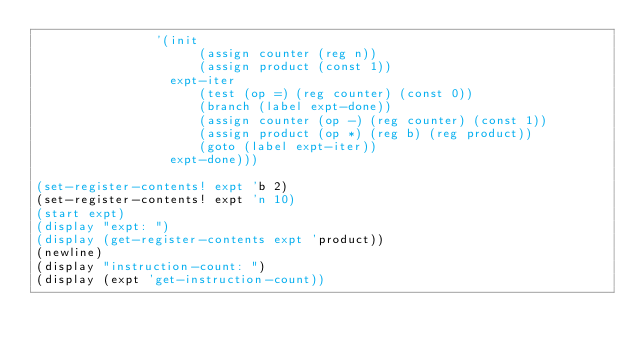<code> <loc_0><loc_0><loc_500><loc_500><_Scheme_>                '(init
                      (assign counter (reg n))
                      (assign product (const 1))
                  expt-iter
                      (test (op =) (reg counter) (const 0))
                      (branch (label expt-done))
                      (assign counter (op -) (reg counter) (const 1))
                      (assign product (op *) (reg b) (reg product))
                      (goto (label expt-iter))
                  expt-done)))

(set-register-contents! expt 'b 2)
(set-register-contents! expt 'n 10)
(start expt)
(display "expt: ")
(display (get-register-contents expt 'product))
(newline)
(display "instruction-count: ")
(display (expt 'get-instruction-count))</code> 